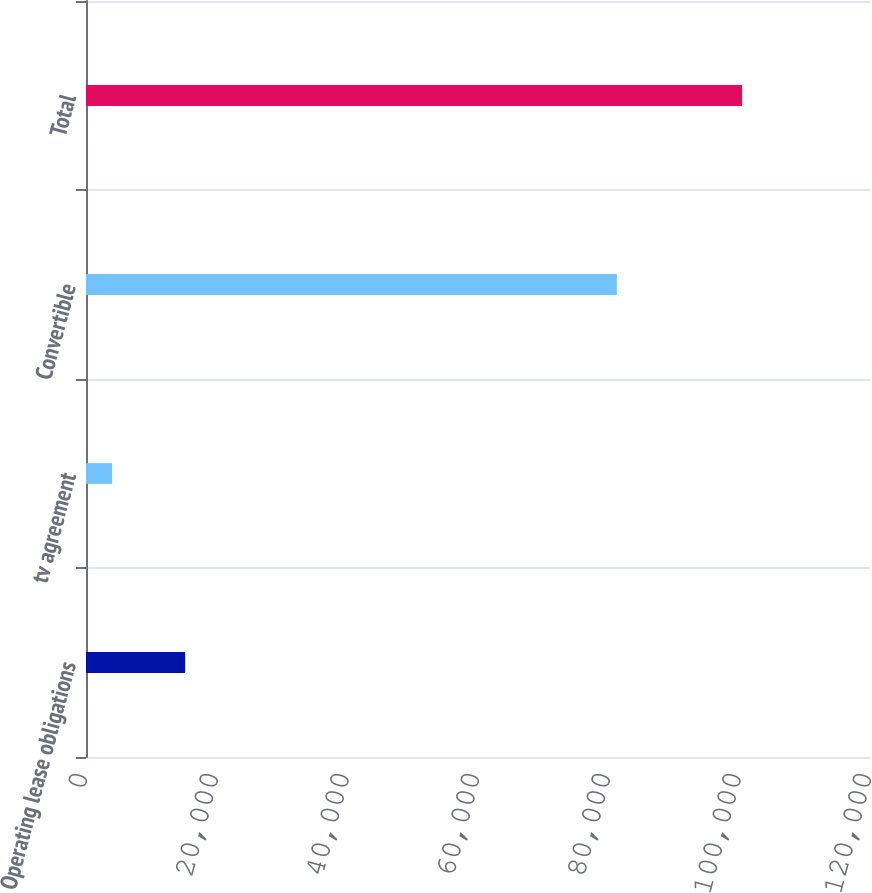Convert chart. <chart><loc_0><loc_0><loc_500><loc_500><bar_chart><fcel>Operating lease obligations<fcel>tv agreement<fcel>Convertible<fcel>Total<nl><fcel>15175<fcel>4000<fcel>81250<fcel>100425<nl></chart> 